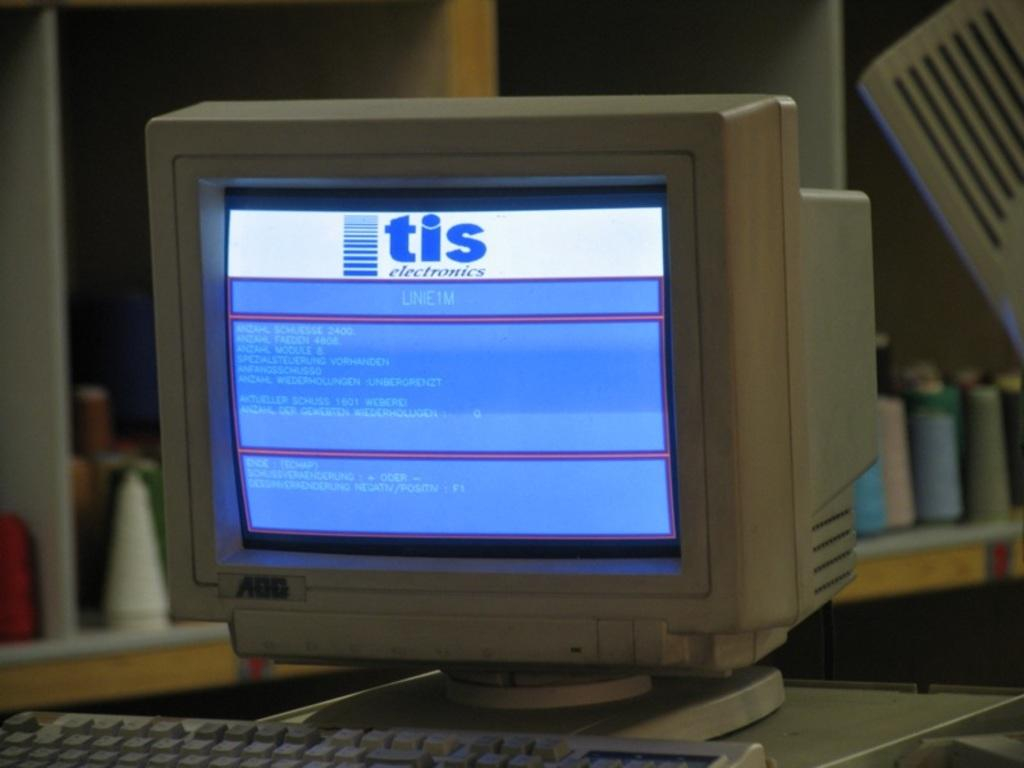<image>
Write a terse but informative summary of the picture. An older computer monitor with a tis electronics page on the screen. 